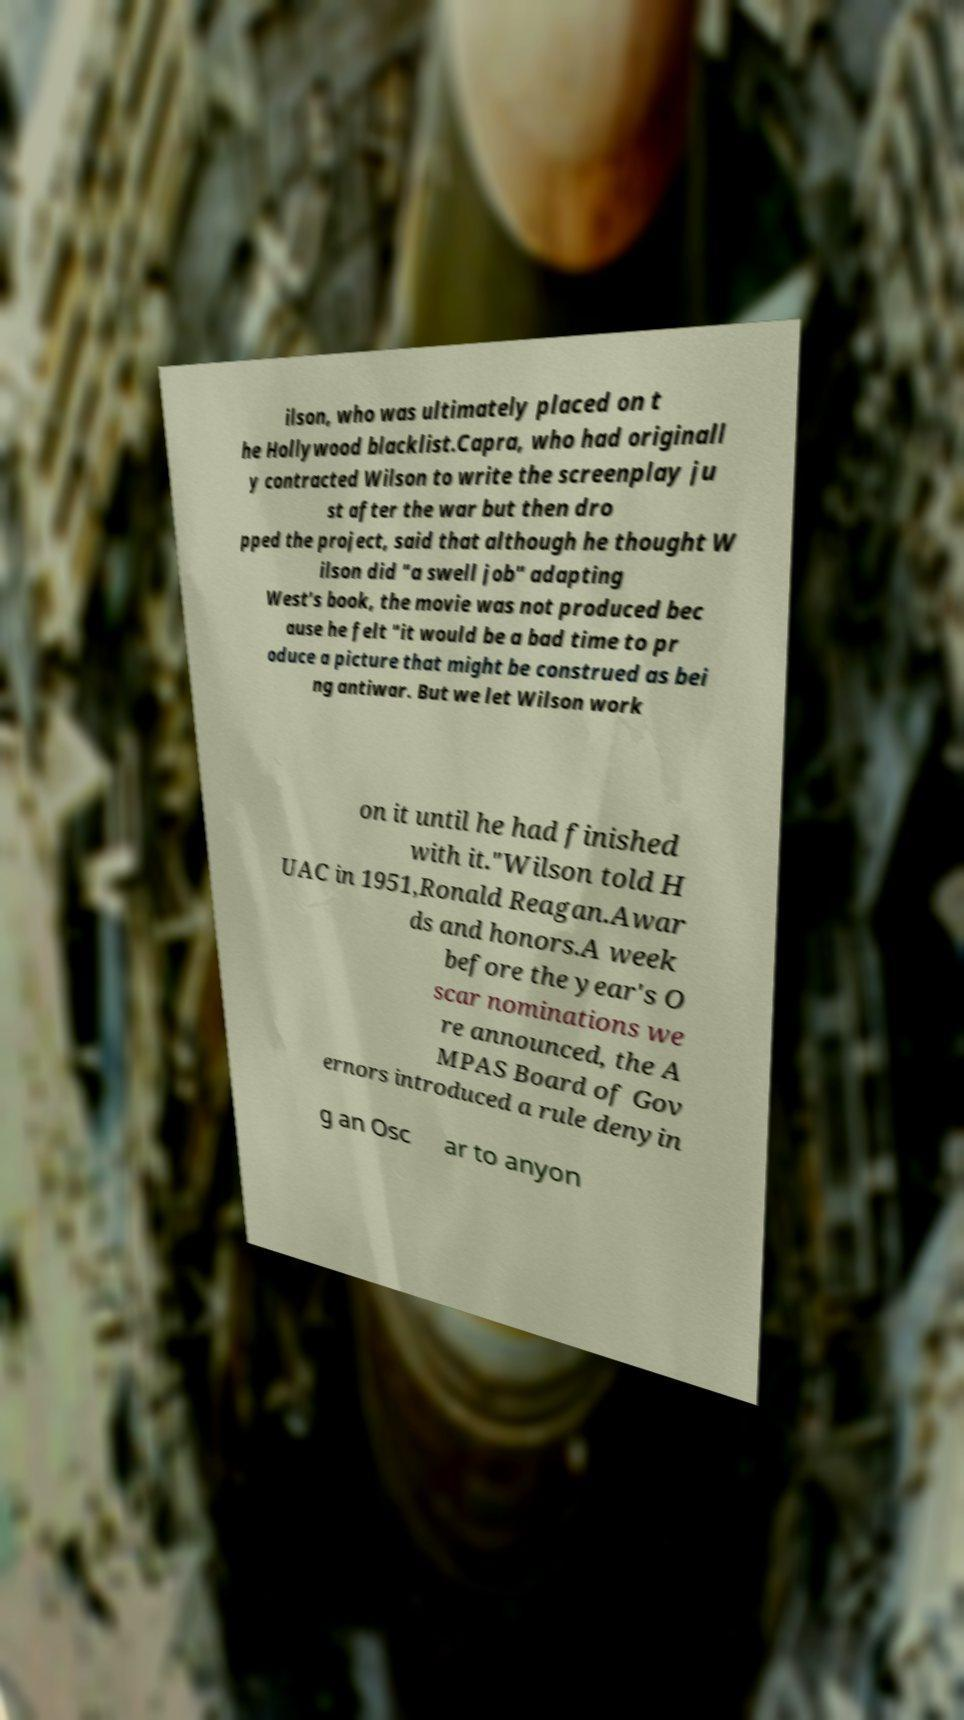Could you extract and type out the text from this image? ilson, who was ultimately placed on t he Hollywood blacklist.Capra, who had originall y contracted Wilson to write the screenplay ju st after the war but then dro pped the project, said that although he thought W ilson did "a swell job" adapting West's book, the movie was not produced bec ause he felt "it would be a bad time to pr oduce a picture that might be construed as bei ng antiwar. But we let Wilson work on it until he had finished with it."Wilson told H UAC in 1951,Ronald Reagan.Awar ds and honors.A week before the year's O scar nominations we re announced, the A MPAS Board of Gov ernors introduced a rule denyin g an Osc ar to anyon 